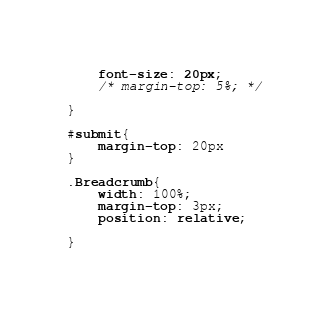Convert code to text. <code><loc_0><loc_0><loc_500><loc_500><_CSS_>    font-size: 20px;
    /* margin-top: 5%; */
    
}

#submit{
    margin-top: 20px
}

.Breadcrumb{
    width: 100%;
    margin-top: 3px;
    position: relative;
    
}</code> 